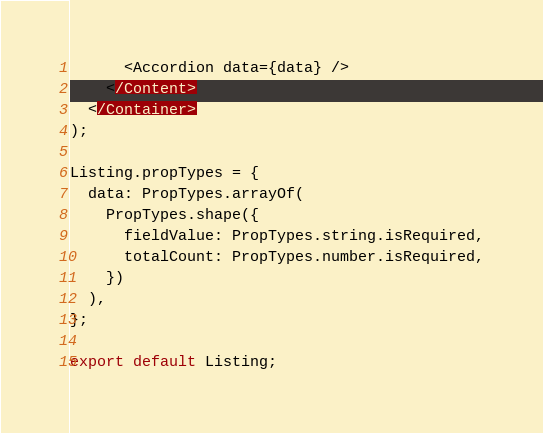Convert code to text. <code><loc_0><loc_0><loc_500><loc_500><_JavaScript_>      <Accordion data={data} />
    </Content>
  </Container>
);

Listing.propTypes = {
  data: PropTypes.arrayOf(
    PropTypes.shape({
      fieldValue: PropTypes.string.isRequired,
      totalCount: PropTypes.number.isRequired,
    })
  ),
};

export default Listing;
</code> 